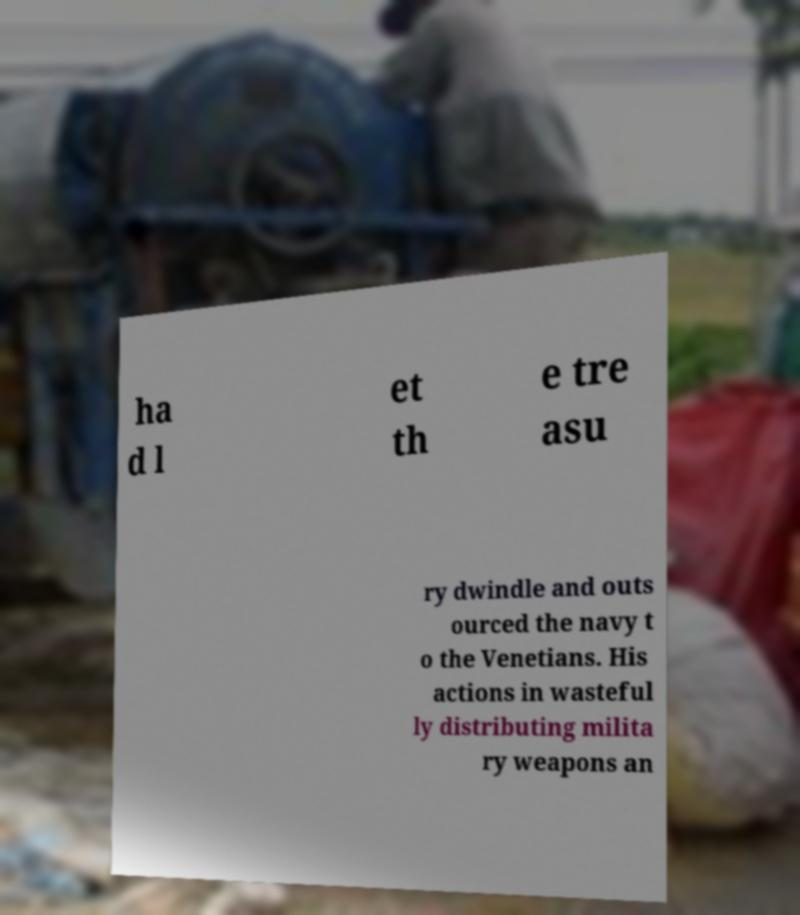Please read and relay the text visible in this image. What does it say? ha d l et th e tre asu ry dwindle and outs ourced the navy t o the Venetians. His actions in wasteful ly distributing milita ry weapons an 